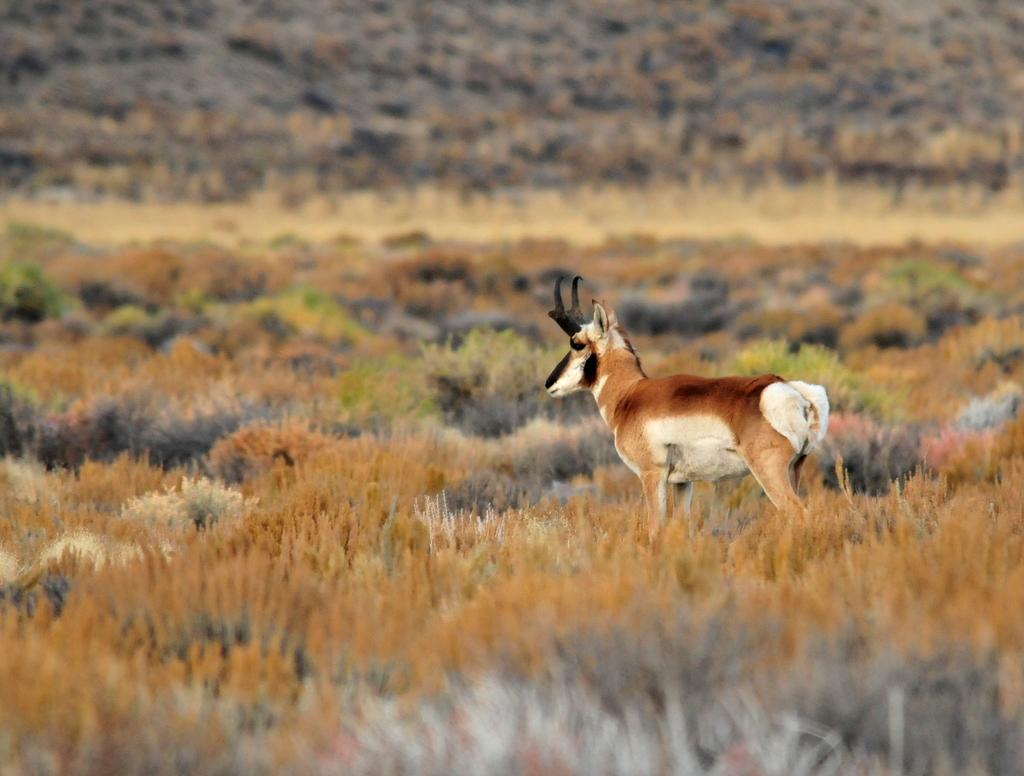What animal can be seen in the image? There is a deer in the image. What celestial bodies are visible in the image? There are a few planets visible in the image. Can you describe the background of the image? The background of the image is blurry. What type of lettuce is being used as a hat by the owl in the image? There is no owl or lettuce present in the image; it features a deer and planets. 